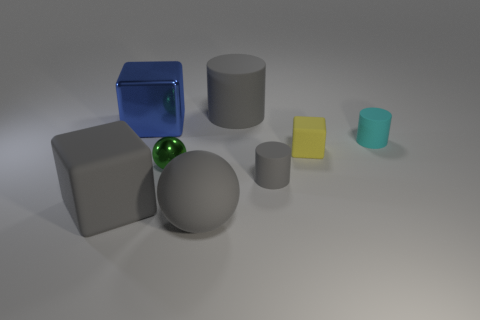Are there the same number of large rubber things in front of the small green thing and blue things?
Ensure brevity in your answer.  No. Is the size of the metallic block the same as the green thing?
Ensure brevity in your answer.  No. There is a matte cube that is the same size as the metal ball; what color is it?
Ensure brevity in your answer.  Yellow. Is the size of the yellow rubber thing the same as the cylinder that is behind the large shiny cube?
Provide a succinct answer. No. How many shiny things have the same color as the metal cube?
Keep it short and to the point. 0. What number of objects are either blue cubes or gray cylinders in front of the cyan cylinder?
Your answer should be very brief. 2. There is a gray rubber cylinder in front of the tiny cyan cylinder; is it the same size as the block to the right of the big gray cylinder?
Offer a terse response. Yes. Are there any other gray cylinders that have the same material as the big gray cylinder?
Provide a short and direct response. Yes. The small cyan thing has what shape?
Make the answer very short. Cylinder. The gray object on the right side of the gray cylinder that is behind the tiny gray rubber cylinder is what shape?
Ensure brevity in your answer.  Cylinder. 